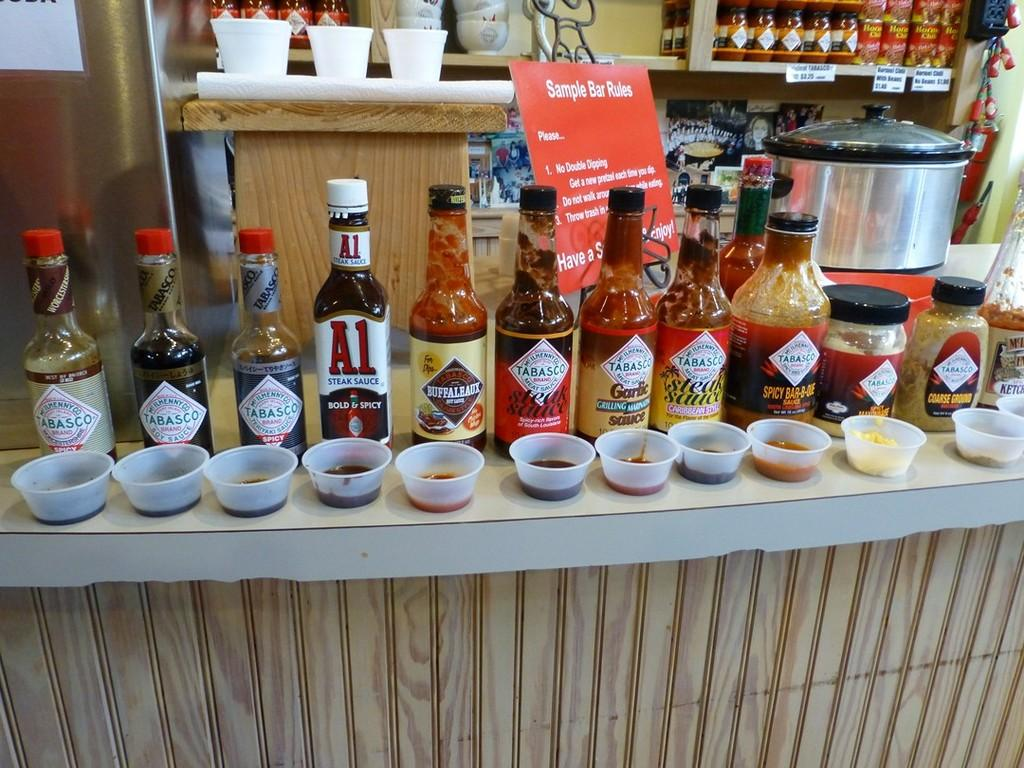<image>
Create a compact narrative representing the image presented. A few bottles of sauces next to each other including tobasco 